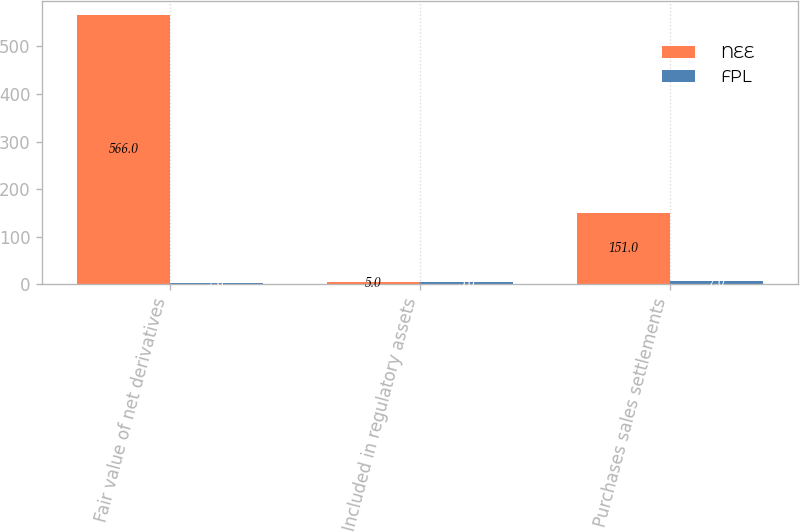Convert chart. <chart><loc_0><loc_0><loc_500><loc_500><stacked_bar_chart><ecel><fcel>Fair value of net derivatives<fcel>Included in regulatory assets<fcel>Purchases sales settlements<nl><fcel>NEE<fcel>566<fcel>5<fcel>151<nl><fcel>FPL<fcel>2<fcel>5<fcel>7<nl></chart> 